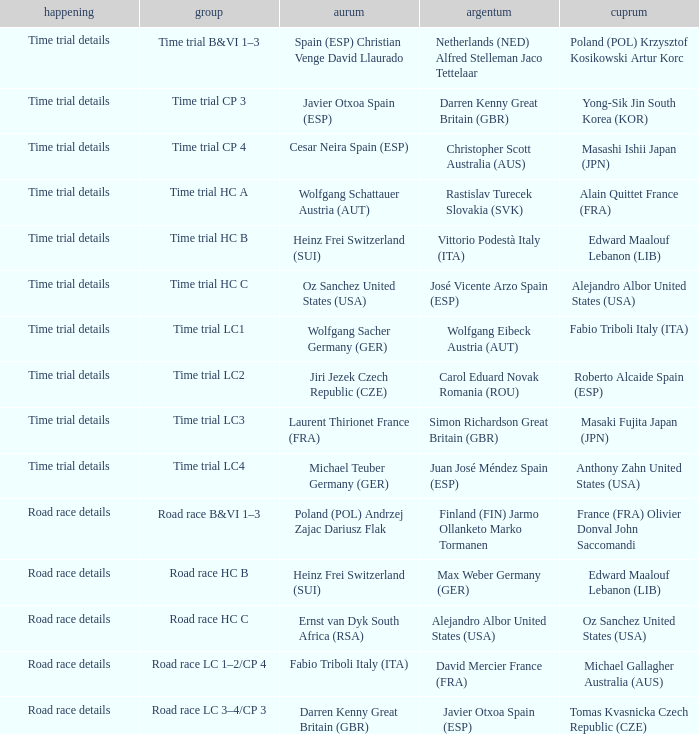Who received gold when the event is time trial details and silver is simon richardson great britain (gbr)? Laurent Thirionet France (FRA). 